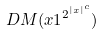<formula> <loc_0><loc_0><loc_500><loc_500>D M ( x 1 ^ { 2 ^ { | x | ^ { c } } } )</formula> 